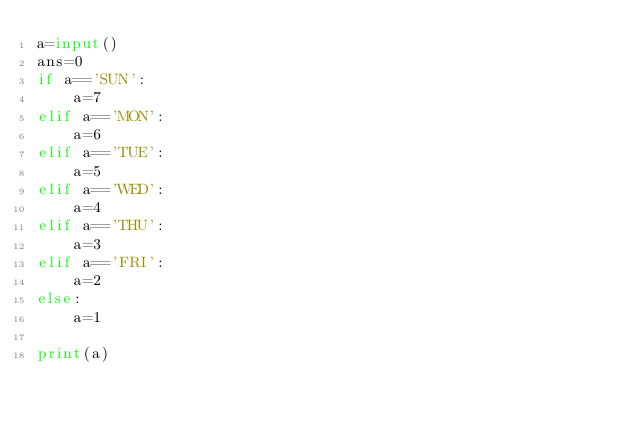Convert code to text. <code><loc_0><loc_0><loc_500><loc_500><_Python_>a=input()
ans=0
if a=='SUN':
    a=7
elif a=='MON':
    a=6
elif a=='TUE':
    a=5
elif a=='WED':
    a=4
elif a=='THU':
    a=3
elif a=='FRI':
    a=2
else:
    a=1

print(a)</code> 